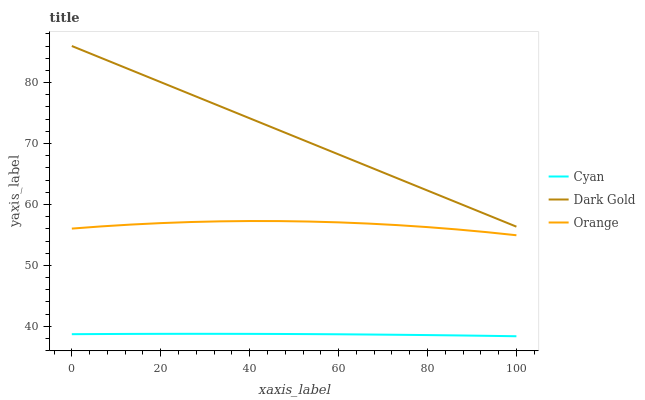Does Dark Gold have the minimum area under the curve?
Answer yes or no. No. Does Cyan have the maximum area under the curve?
Answer yes or no. No. Is Cyan the smoothest?
Answer yes or no. No. Is Cyan the roughest?
Answer yes or no. No. Does Dark Gold have the lowest value?
Answer yes or no. No. Does Cyan have the highest value?
Answer yes or no. No. Is Cyan less than Orange?
Answer yes or no. Yes. Is Orange greater than Cyan?
Answer yes or no. Yes. Does Cyan intersect Orange?
Answer yes or no. No. 